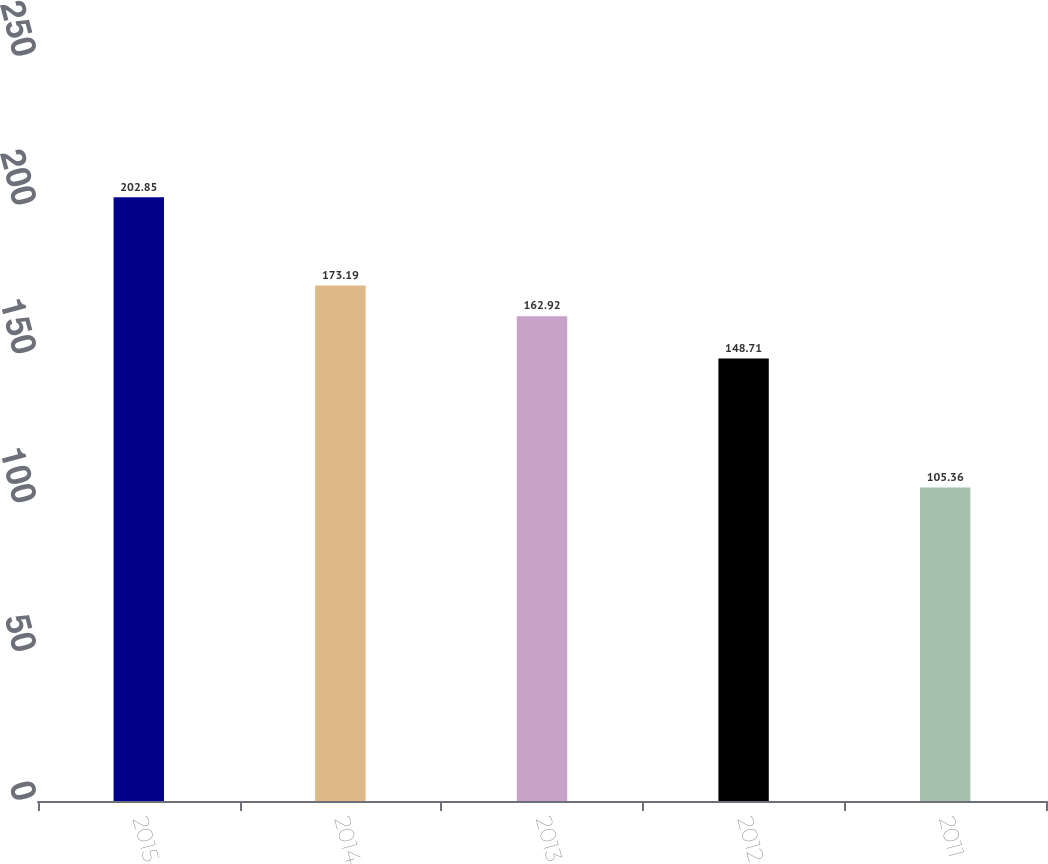Convert chart. <chart><loc_0><loc_0><loc_500><loc_500><bar_chart><fcel>2015<fcel>2014<fcel>2013<fcel>2012<fcel>2011<nl><fcel>202.85<fcel>173.19<fcel>162.92<fcel>148.71<fcel>105.36<nl></chart> 